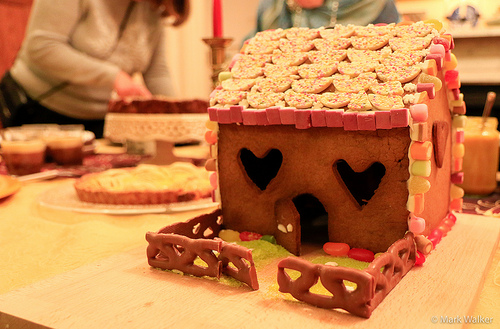<image>
Is there a fence on the table? Yes. Looking at the image, I can see the fence is positioned on top of the table, with the table providing support. 